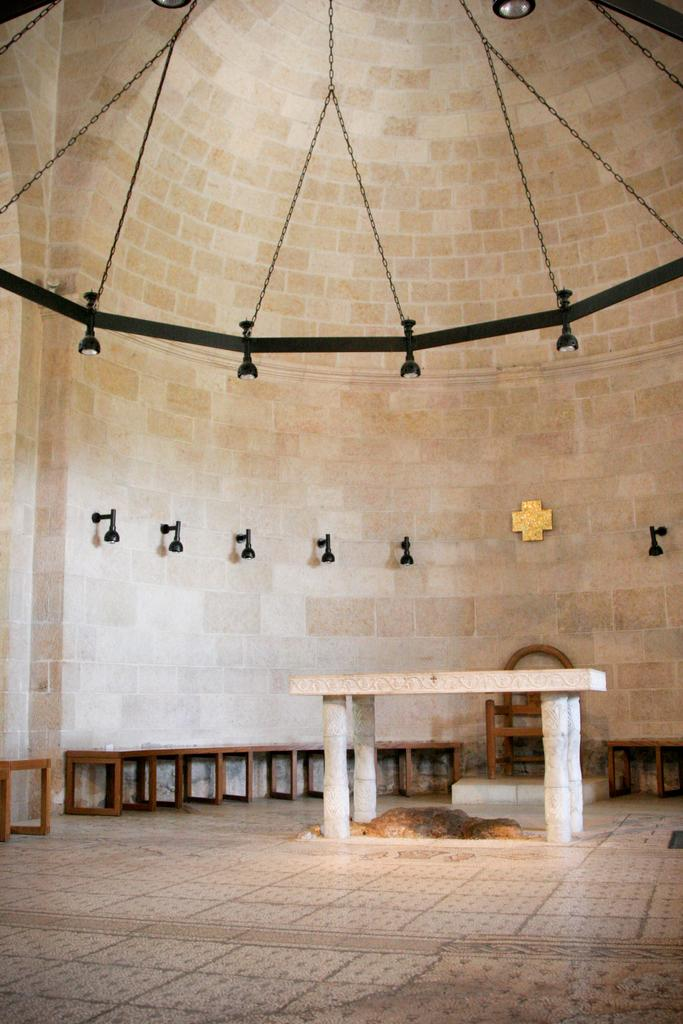What type of furniture is on the ground in the image? There are benches on the ground in the image. What can be seen in the background of the image? There is a wall and lights visible in the background of the image. Are there any other objects in the background of the image? Yes, there are some objects in the background of the image. Can you see a smile on the benches in the image? There are no smiles present in the image, as benches are inanimate objects and cannot display emotions. 